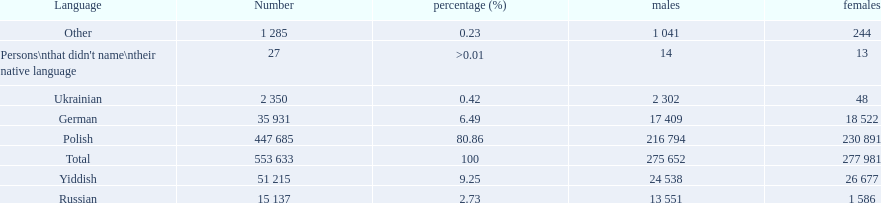What were the languages in plock governorate? Polish, Yiddish, German, Russian, Ukrainian, Other. Which language has a value of .42? Ukrainian. 